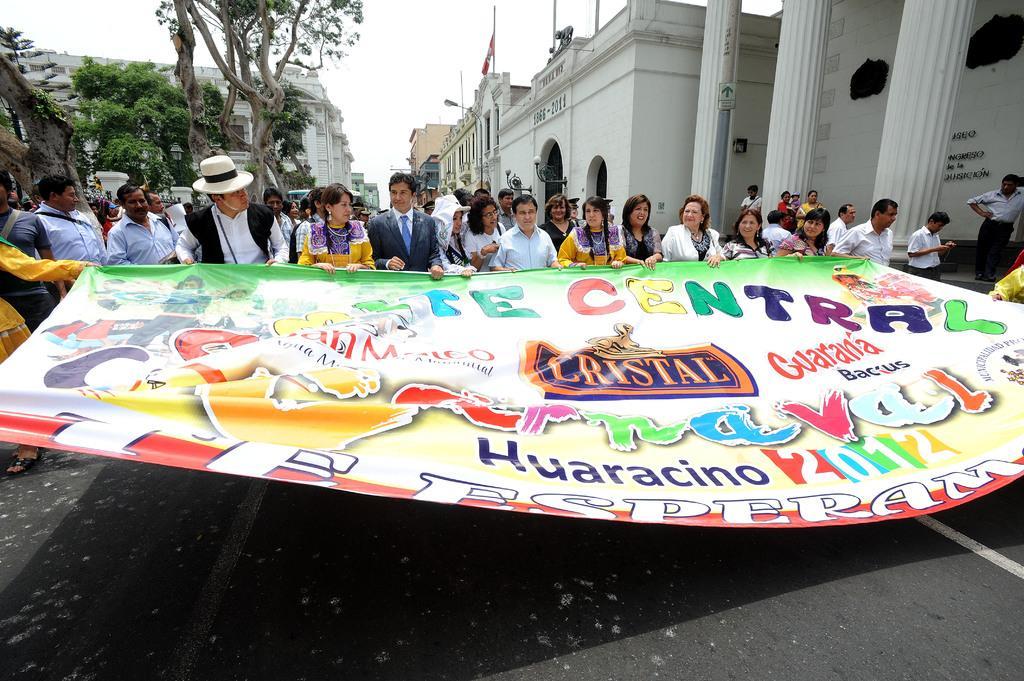Can you describe this image briefly? In this picture we can see some people are standing, some of them are holding banner, there is some text on this banner, in the background there are some buildings, on the left side we can see trees, there is the sky at the top of the picture, we can see a light and a flag in the middle. 